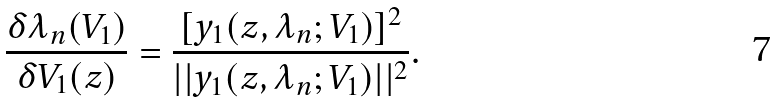Convert formula to latex. <formula><loc_0><loc_0><loc_500><loc_500>\frac { \delta \lambda _ { n } ( V _ { 1 } ) } { \delta V _ { 1 } ( z ) } = \frac { [ y _ { 1 } ( z , \lambda _ { n } ; V _ { 1 } ) ] ^ { 2 } } { | | y _ { 1 } ( z , \lambda _ { n } ; V _ { 1 } ) | | ^ { 2 } } .</formula> 